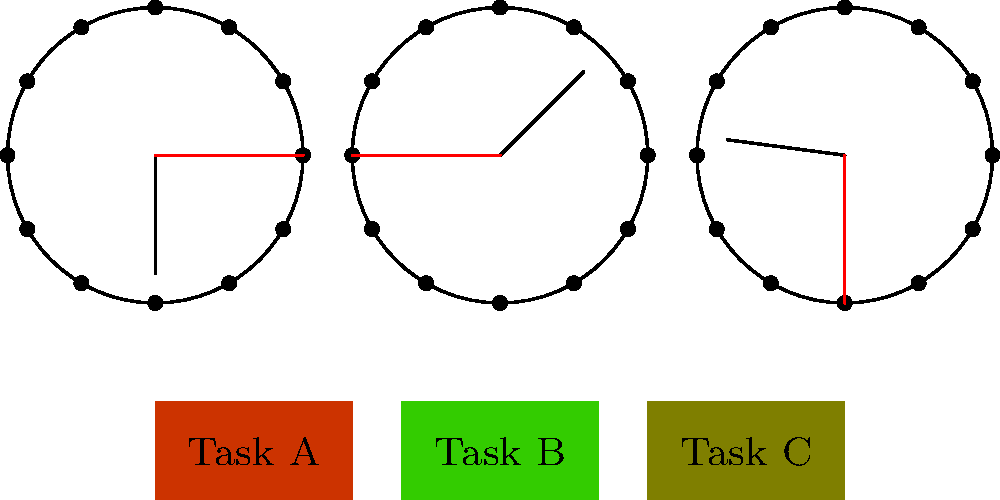As a business coach focusing on success traits, analyze the graphic representation of time management skills. Which task should be prioritized based on the clock faces and task prioritization shown? To answer this question, we need to analyze the graphic representation step by step:

1. Clock faces:
   - The first clock shows 9:00
   - The second clock shows 1:30
   - The third clock shows 5:45

2. Task prioritization:
   - Task A: Green color (low priority)
   - Task B: Red color (high priority)
   - Task C: Yellow color (medium priority)

3. Interpreting the information:
   - The clocks likely represent different times of the day: morning, early afternoon, and late afternoon.
   - The color-coding of tasks indicates their priority levels.

4. Time management principle:
   - In effective time management, high-priority tasks should be addressed first, especially during peak productivity hours (usually in the morning).

5. Conclusion:
   - Task B has the highest priority (red color).
   - The first clock shows 9:00, which is typically a high-productivity time in the morning.

Therefore, based on the time management skills represented in the graphic, Task B should be prioritized and tackled during the morning hours shown by the first clock.
Answer: Task B 